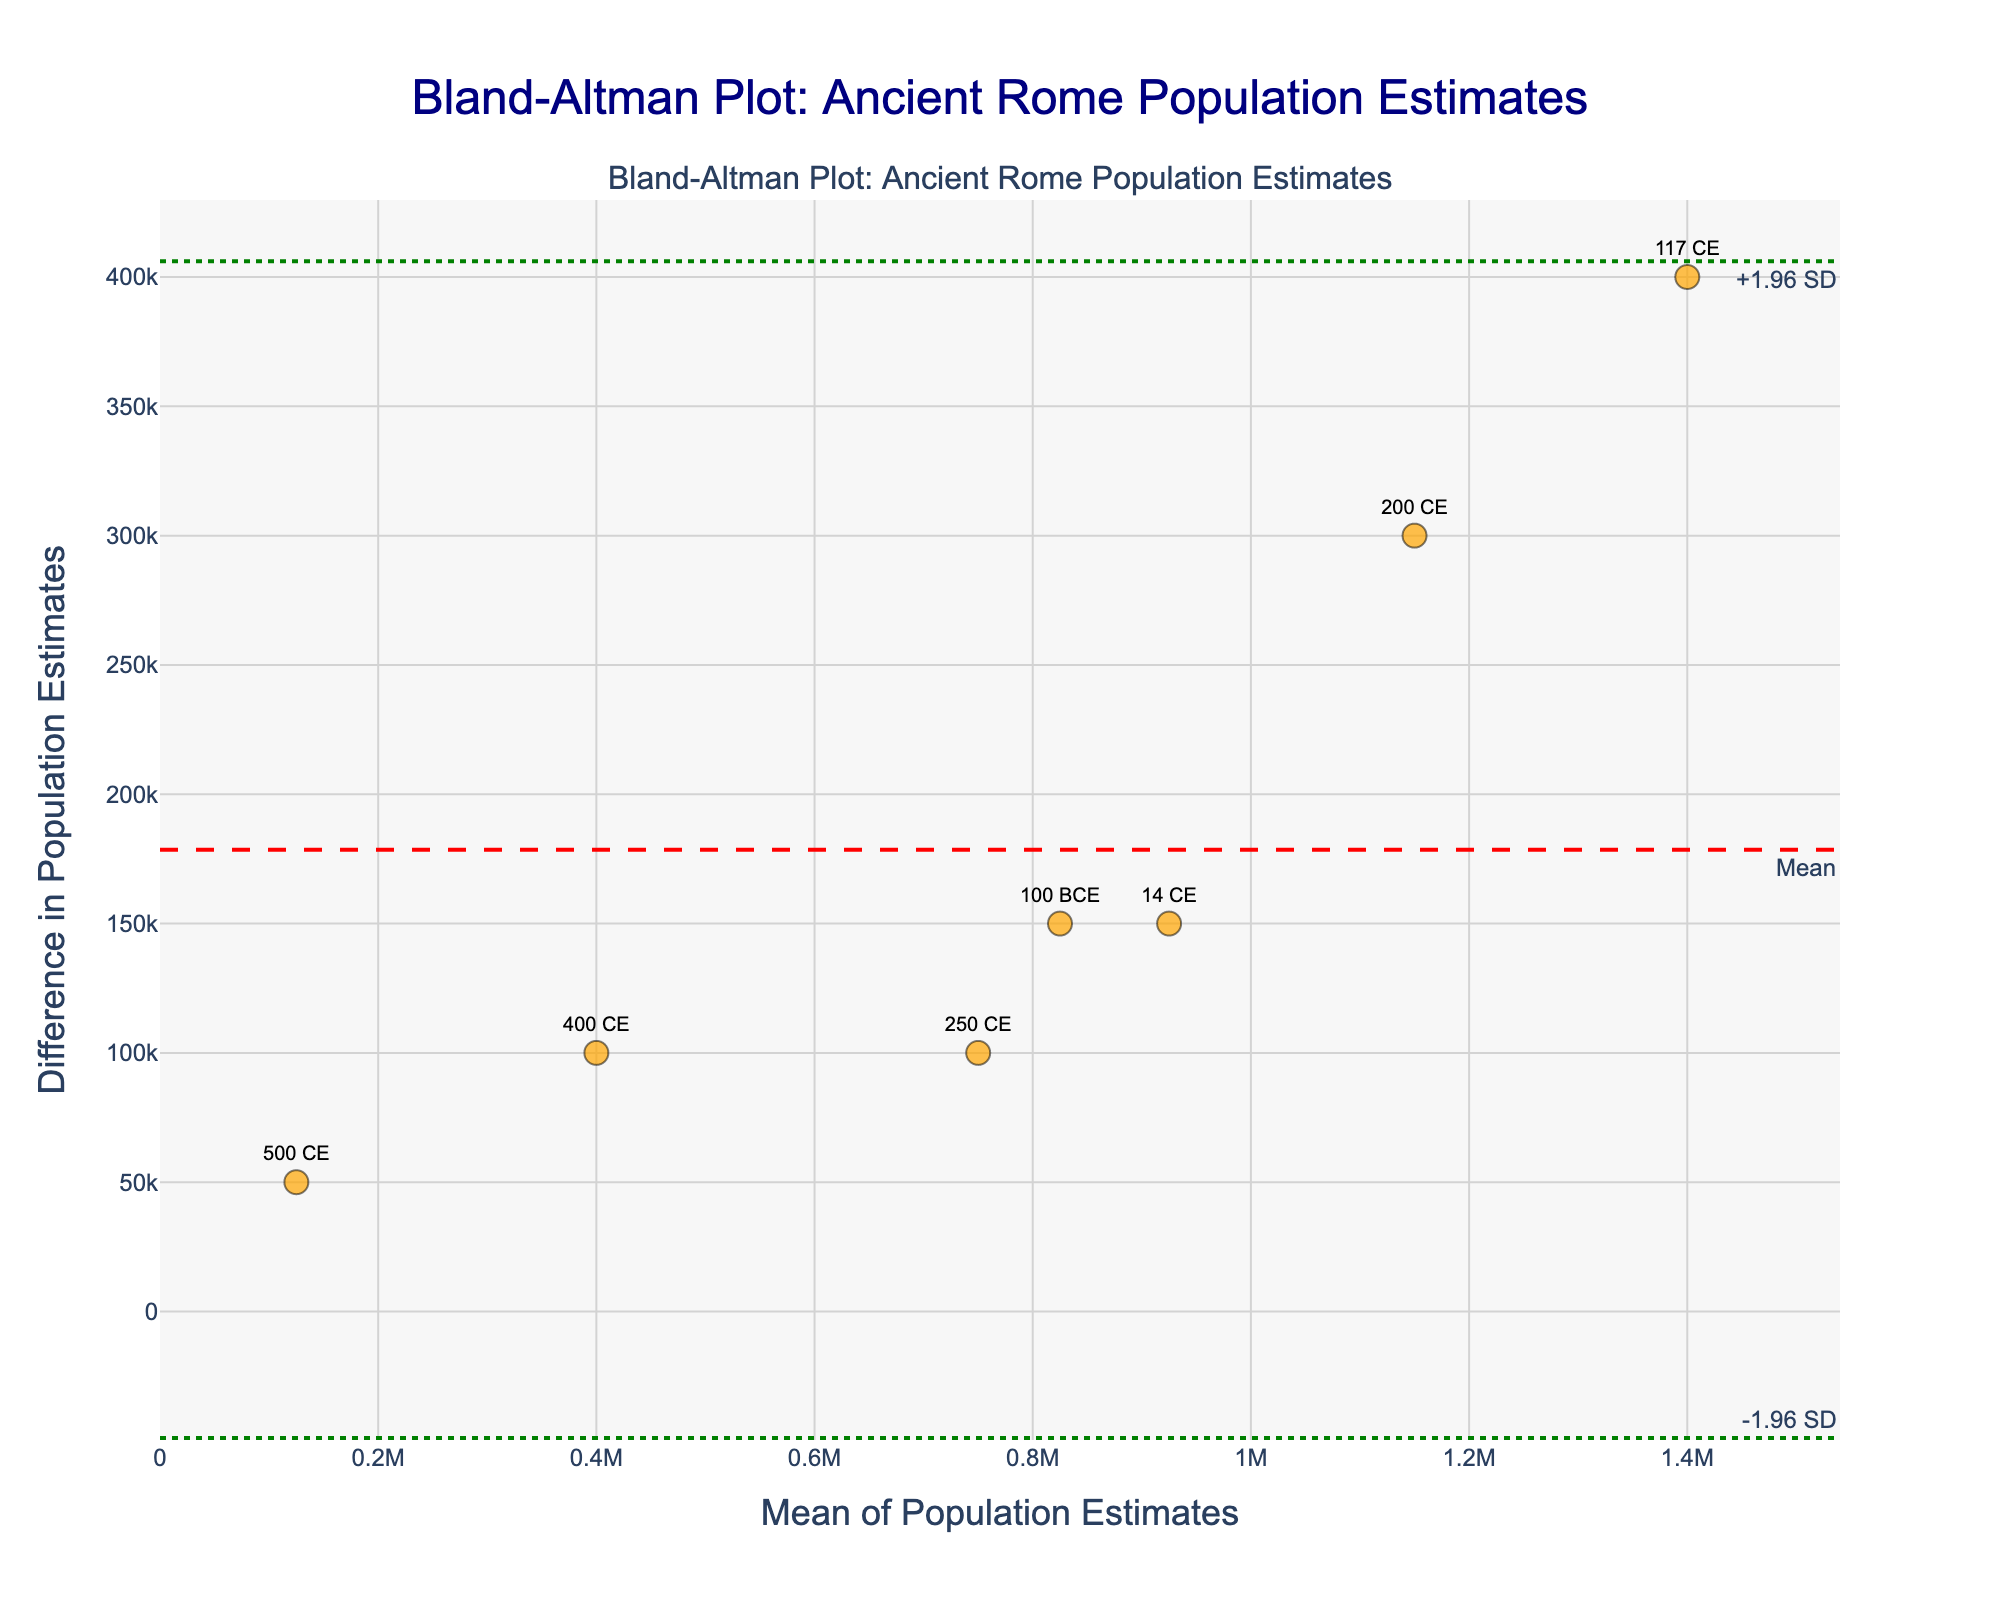How many data points are plotted on the figure? By counting the number of markers on the plot, we can determine the number of data points. Each marker represents a pair of population estimates from different sources plotted on the Bland-Altman plot. There are 7 markers corresponding to 7 data points.
Answer: 7 What is the title of the figure? The title of the figure is located at the top center of the plot. It helps to identify the type and context of the plot. The title in the provided Bland-Altman plot is "Bland-Altman Plot: Ancient Rome Population Estimates."
Answer: Bland-Altman Plot: Ancient Rome Population Estimates What is the mean difference between the population estimates in the figure? The mean difference is visually represented by a horizontal dashed red line. The annotation next to this line indicates its value. In the plot, the mean difference is shown on the red dashed line with the annotation "Mean."
Answer: Mean Which data point has the highest mean of population estimates? The mean of population estimates for each point is plotted on the x-axis. By looking at the rightmost point on the x-axis, we can identify the highest mean. The data point from 117 CE has the highest mean, where the mean of the population estimates is (1200000 + 1600000) / 2 = 1400000.
Answer: 117 CE Among the limits of agreement lines, what are the values for +1.96 SD and -1.96 SD? The limits of agreement lines are represented by green dotted lines. The annotations next to these lines indicate their values. The upper limit (+1.96 SD) and the lower limit (-1.96 SD) are noted on the plot.
Answer: +1.96 SD, -1.96 SD What is the difference in population estimates from 500 CE? To find this, locate the data point labeled "500 CE" and look at its y-axis value, which represents the difference in population estimates. The difference between the population estimates for 500 CE is 150000 - 100000 = 50000.
Answer: 50000 Is there any bias in the population estimates? The presence of bias in the estimates can be inferred by examining whether the mean difference (red dashed line) is centered around zero or if there is a trend in the differences. A significant deviation from zero or a non-random distribution of differences indicates bias. In this plot, the mean difference line does not seem centered at zero, suggesting potential bias.
Answer: Yes Which data point has the smallest difference between population estimates? The smallest difference is shown by the data point closest to the zero line on the y-axis. By visually inspecting, the data point labeled "250 CE" has the smallest difference where the difference is 800000 - 700000 = 100000.
Answer: 250 CE Which data point lies closest to the upper limit of agreement ( +1.96 SD)? Identify the data point nearest to the upper limit of agreement line represented by the green dotted line labeled "+1.96 SD." The data point from 117 CE lies closest to this line.
Answer: 117 CE 